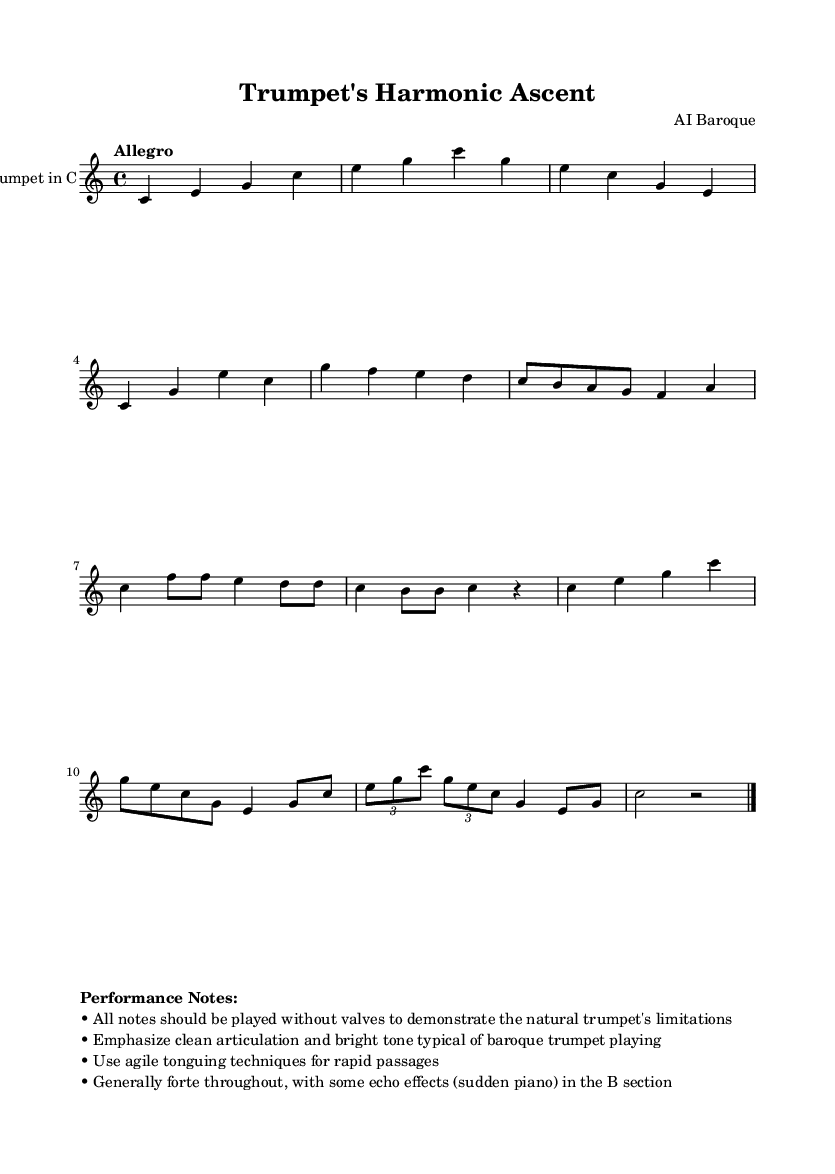What is the key signature of this music? The key signature is at the beginning of the staff, which shows no sharps or flats, indicating it is in C major.
Answer: C major What is the tempo marking of this piece? The tempo marking is displayed above the staff, stating "Allegro," which indicates a fast and lively speed for the performance.
Answer: Allegro How many measures are there in section A? By counting the four-bar phrases in the A section, we find there are 4 measures in total, with each phrase separated clearly by vertical lines.
Answer: 4 What type of trumpet is indicated in the score? The instrument specified at the beginning of the score is "Trumpet in C," which tells us both the type of trumpet and the tuning.
Answer: Trumpet in C What dynamic is generally indicated for this composition? The performance notes mention to play generally forte, highlighting the intended loudness for most of the piece, particularly in section A.
Answer: Forte How does the B section contrast with section A regarding dynamics? The B section includes sudden shifts to piano ("echo effects"), contrasting with the predominantly forte dynamic found in section A, indicating a dynamic change.
Answer: Sudden piano What technique is recommended for rapid passages in this piece? The performance notes suggest using "agile tonguing techniques," which is essential for executing rapid passages clearly on the trumpet.
Answer: Agile tonguing techniques 